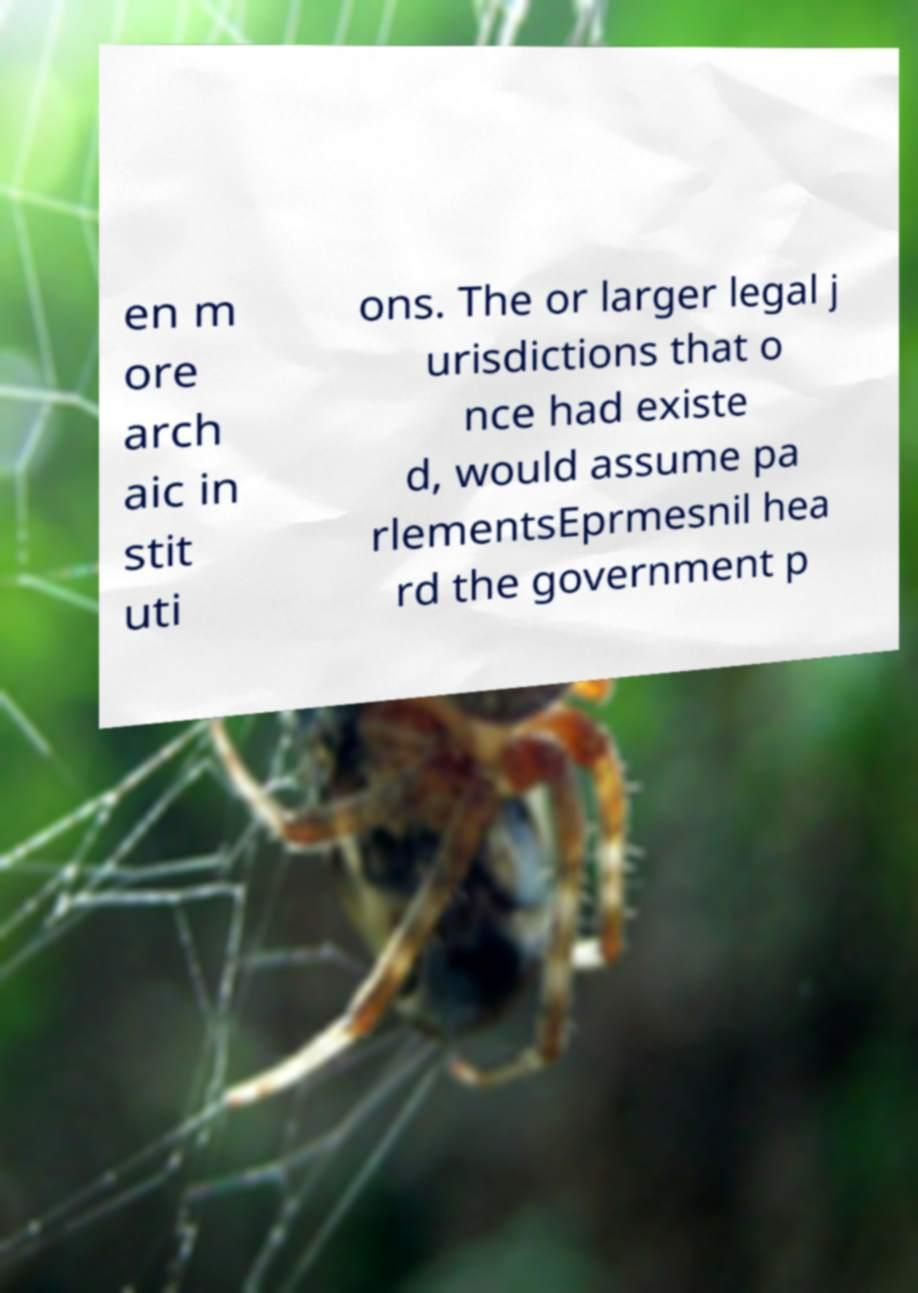Please read and relay the text visible in this image. What does it say? en m ore arch aic in stit uti ons. The or larger legal j urisdictions that o nce had existe d, would assume pa rlementsEprmesnil hea rd the government p 